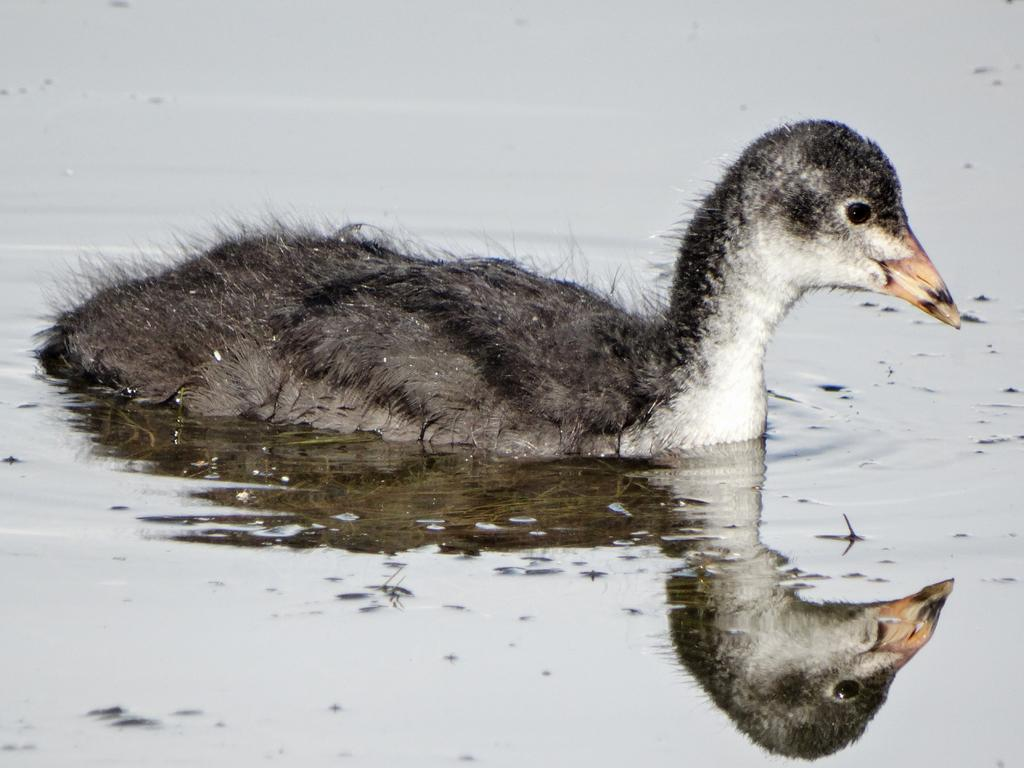What type of animal is in the image? There is a bird in the image. Where is the bird located? The bird is on the water. What type of paper is the judge holding in the image? There is no judge or paper present in the image; it features a bird on the water. 